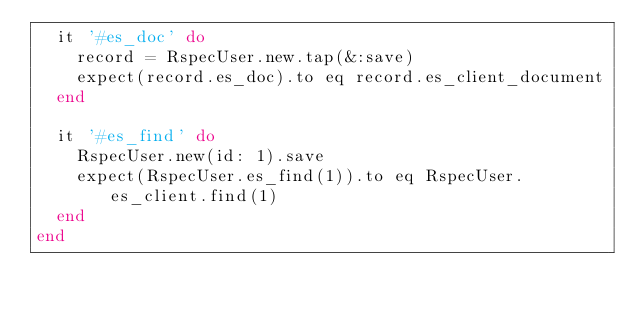Convert code to text. <code><loc_0><loc_0><loc_500><loc_500><_Ruby_>  it '#es_doc' do
    record = RspecUser.new.tap(&:save)
    expect(record.es_doc).to eq record.es_client_document
  end

  it '#es_find' do
    RspecUser.new(id: 1).save
    expect(RspecUser.es_find(1)).to eq RspecUser.es_client.find(1)
  end
end</code> 